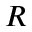Convert formula to latex. <formula><loc_0><loc_0><loc_500><loc_500>R</formula> 